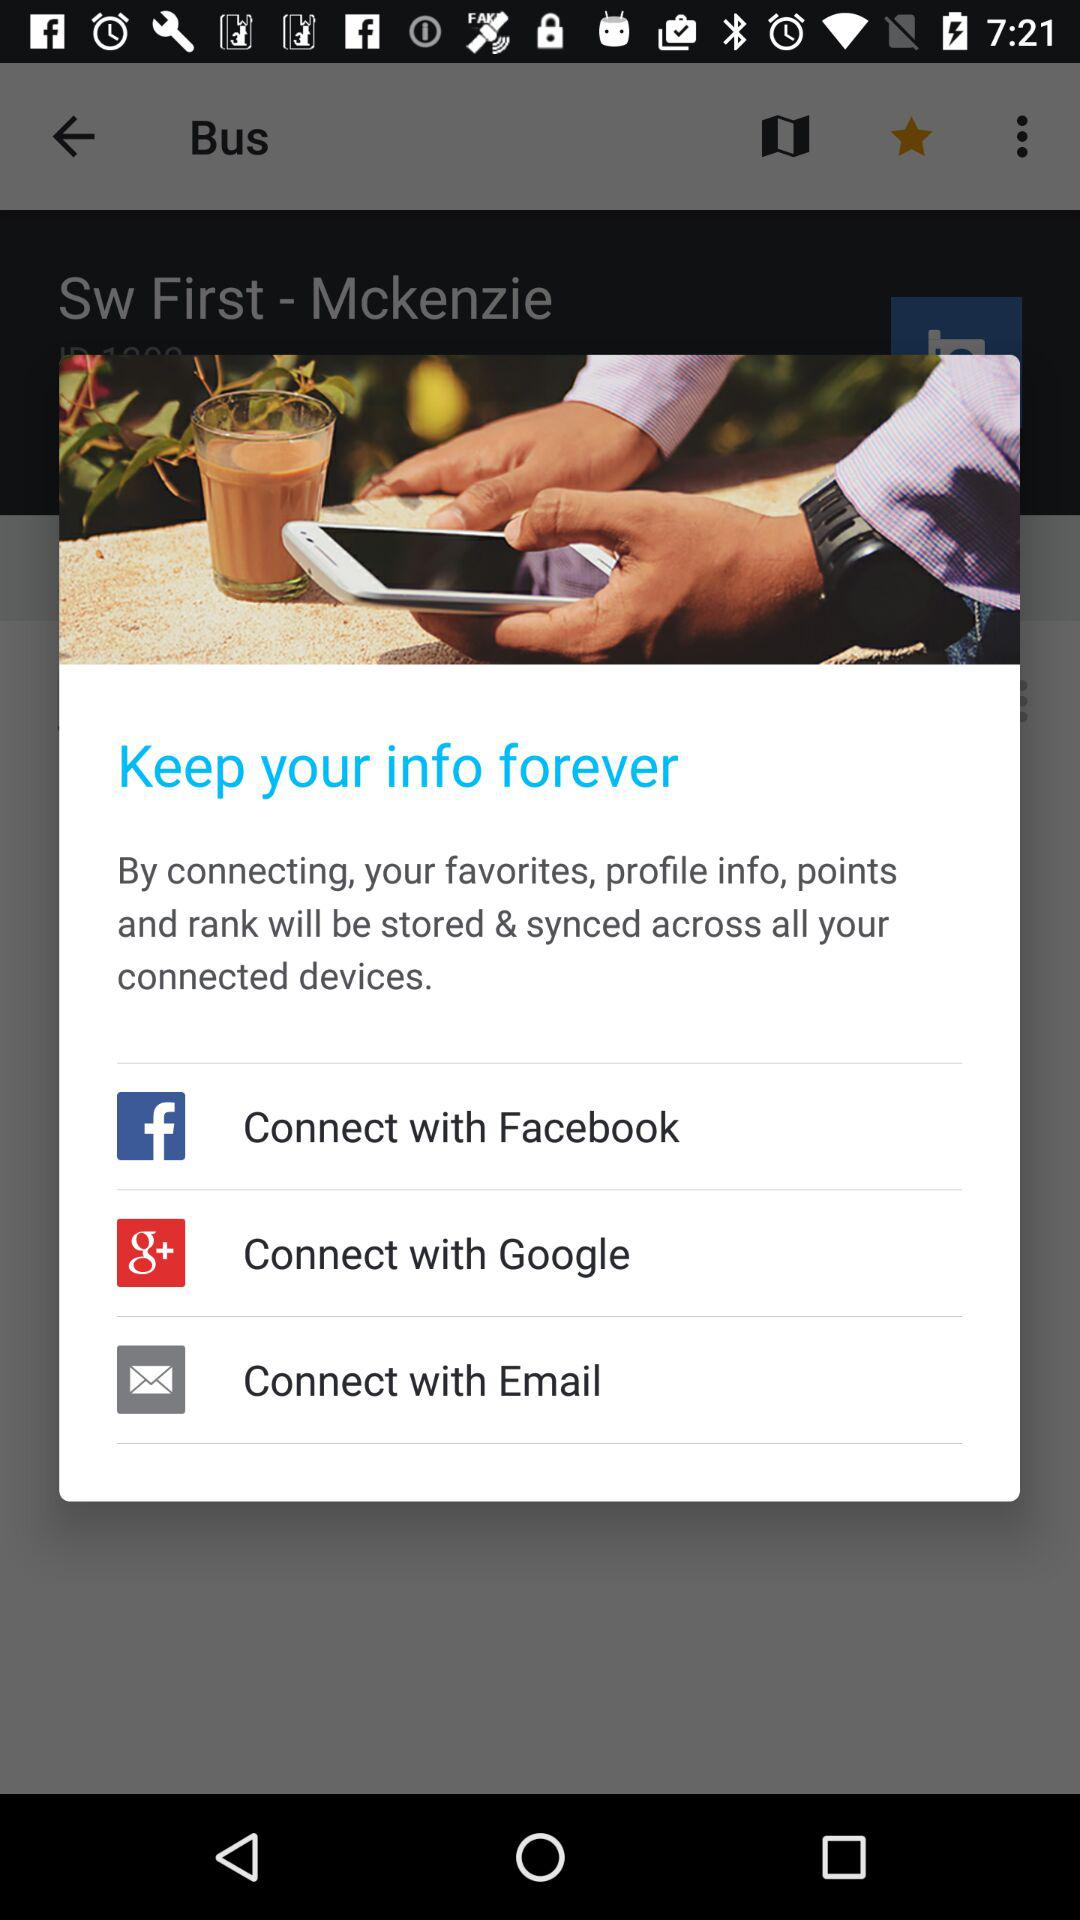Through what applications can we connect? You can connect with "Facebook", "Google" and "Email". 